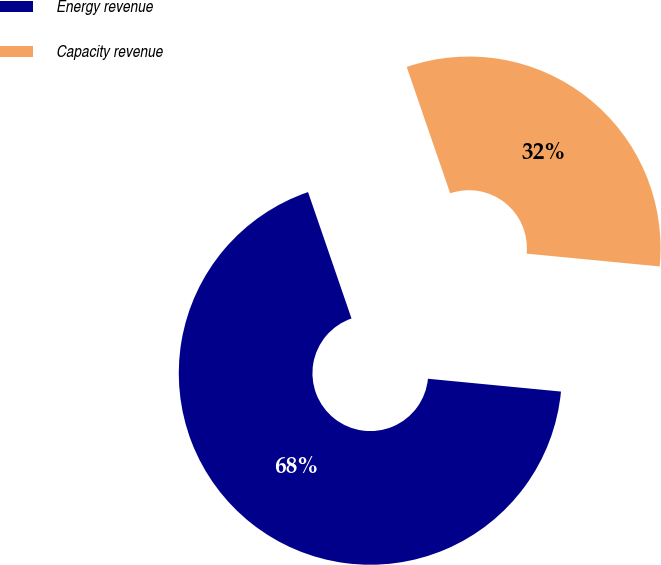Convert chart. <chart><loc_0><loc_0><loc_500><loc_500><pie_chart><fcel>Energy revenue<fcel>Capacity revenue<nl><fcel>68.2%<fcel>31.8%<nl></chart> 